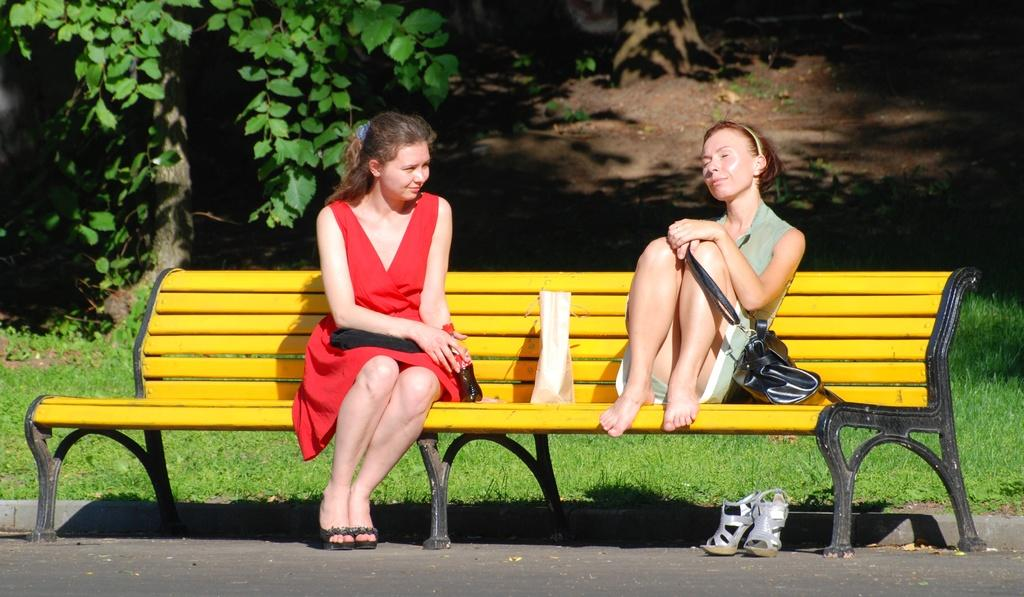What type of plant can be seen in the image? There is a tree in the image. How many people are present in the image? There are two women in the image. What are the women doing in the image? The women are sitting on a bench. How many credits are being exchanged between the women in the image? There is no mention of credits or any form of exchange in the image; it simply shows two women sitting on a bench. How many babies are present in the image? There are no babies present in the image; it features two women sitting on a bench. 